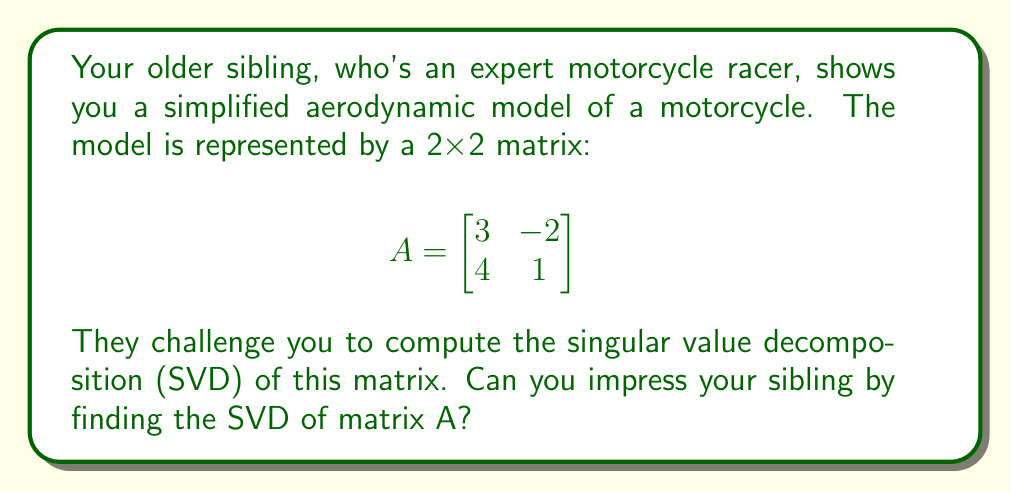Help me with this question. To find the singular value decomposition (SVD) of matrix A, we need to follow these steps:

1) First, calculate $A^TA$:
   $$A^TA = \begin{bmatrix}
   3 & 4 \\
   -2 & 1
   \end{bmatrix} \begin{bmatrix}
   3 & -2 \\
   4 & 1
   \end{bmatrix} = \begin{bmatrix}
   25 & -2 \\
   -2 & 5
   \end{bmatrix}$$

2) Find the eigenvalues of $A^TA$ by solving the characteristic equation:
   $$det(A^TA - \lambda I) = \begin{vmatrix}
   25-\lambda & -2 \\
   -2 & 5-\lambda
   \end{vmatrix} = (25-\lambda)(5-\lambda) - 4 = \lambda^2 - 30\lambda + 121 = 0$$
   
   Solving this quadratic equation gives: $\lambda_1 = 26$ and $\lambda_2 = 4$

3) The singular values are the square roots of these eigenvalues:
   $\sigma_1 = \sqrt{26}$ and $\sigma_2 = 2$

4) To find the right singular vectors, solve $(A^TA - \lambda_i I)v_i = 0$ for each $\lambda_i$:
   For $\lambda_1 = 26$:
   $$\begin{bmatrix}
   -1 & -2 \\
   -2 & -21
   \end{bmatrix} \begin{bmatrix}
   v_{11} \\
   v_{21}
   \end{bmatrix} = \begin{bmatrix}
   0 \\
   0
   \end{bmatrix}$$
   This gives $v_1 = [\frac{2}{\sqrt{5}}, \frac{1}{\sqrt{5}}]^T$

   For $\lambda_2 = 4$:
   $$\begin{bmatrix}
   21 & -2 \\
   -2 & 1
   \end{bmatrix} \begin{bmatrix}
   v_{12} \\
   v_{22}
   \end{bmatrix} = \begin{bmatrix}
   0 \\
   0
   \end{bmatrix}$$
   This gives $v_2 = [-\frac{1}{\sqrt{5}}, \frac{2}{\sqrt{5}}]^T$

5) To find the left singular vectors, use $u_i = \frac{1}{\sigma_i}Av_i$:
   $$u_1 = \frac{1}{\sqrt{26}}\begin{bmatrix}
   3 & -2 \\
   4 & 1
   \end{bmatrix} \begin{bmatrix}
   \frac{2}{\sqrt{5}} \\
   \frac{1}{\sqrt{5}}
   \end{bmatrix} = [\frac{3}{\sqrt{13}}, \frac{2}{\sqrt{13}}]^T$$
   
   $$u_2 = \frac{1}{2}\begin{bmatrix}
   3 & -2 \\
   4 & 1
   \end{bmatrix} \begin{bmatrix}
   -\frac{1}{\sqrt{5}} \\
   \frac{2}{\sqrt{5}}
   \end{bmatrix} = [-\frac{2}{\sqrt{13}}, \frac{3}{\sqrt{13}}]^T$$

Therefore, the SVD of A is:
$$A = U\Sigma V^T = \begin{bmatrix}
\frac{3}{\sqrt{13}} & -\frac{2}{\sqrt{13}} \\
\frac{2}{\sqrt{13}} & \frac{3}{\sqrt{13}}
\end{bmatrix} \begin{bmatrix}
\sqrt{26} & 0 \\
0 & 2
\end{bmatrix} \begin{bmatrix}
\frac{2}{\sqrt{5}} & -\frac{1}{\sqrt{5}} \\
\frac{1}{\sqrt{5}} & \frac{2}{\sqrt{5}}
\end{bmatrix}^T$$
Answer: $A = \begin{bmatrix}
\frac{3}{\sqrt{13}} & -\frac{2}{\sqrt{13}} \\
\frac{2}{\sqrt{13}} & \frac{3}{\sqrt{13}}
\end{bmatrix} \begin{bmatrix}
\sqrt{26} & 0 \\
0 & 2
\end{bmatrix} \begin{bmatrix}
\frac{2}{\sqrt{5}} & \frac{1}{\sqrt{5}} \\
-\frac{1}{\sqrt{5}} & \frac{2}{\sqrt{5}}
\end{bmatrix}$ 